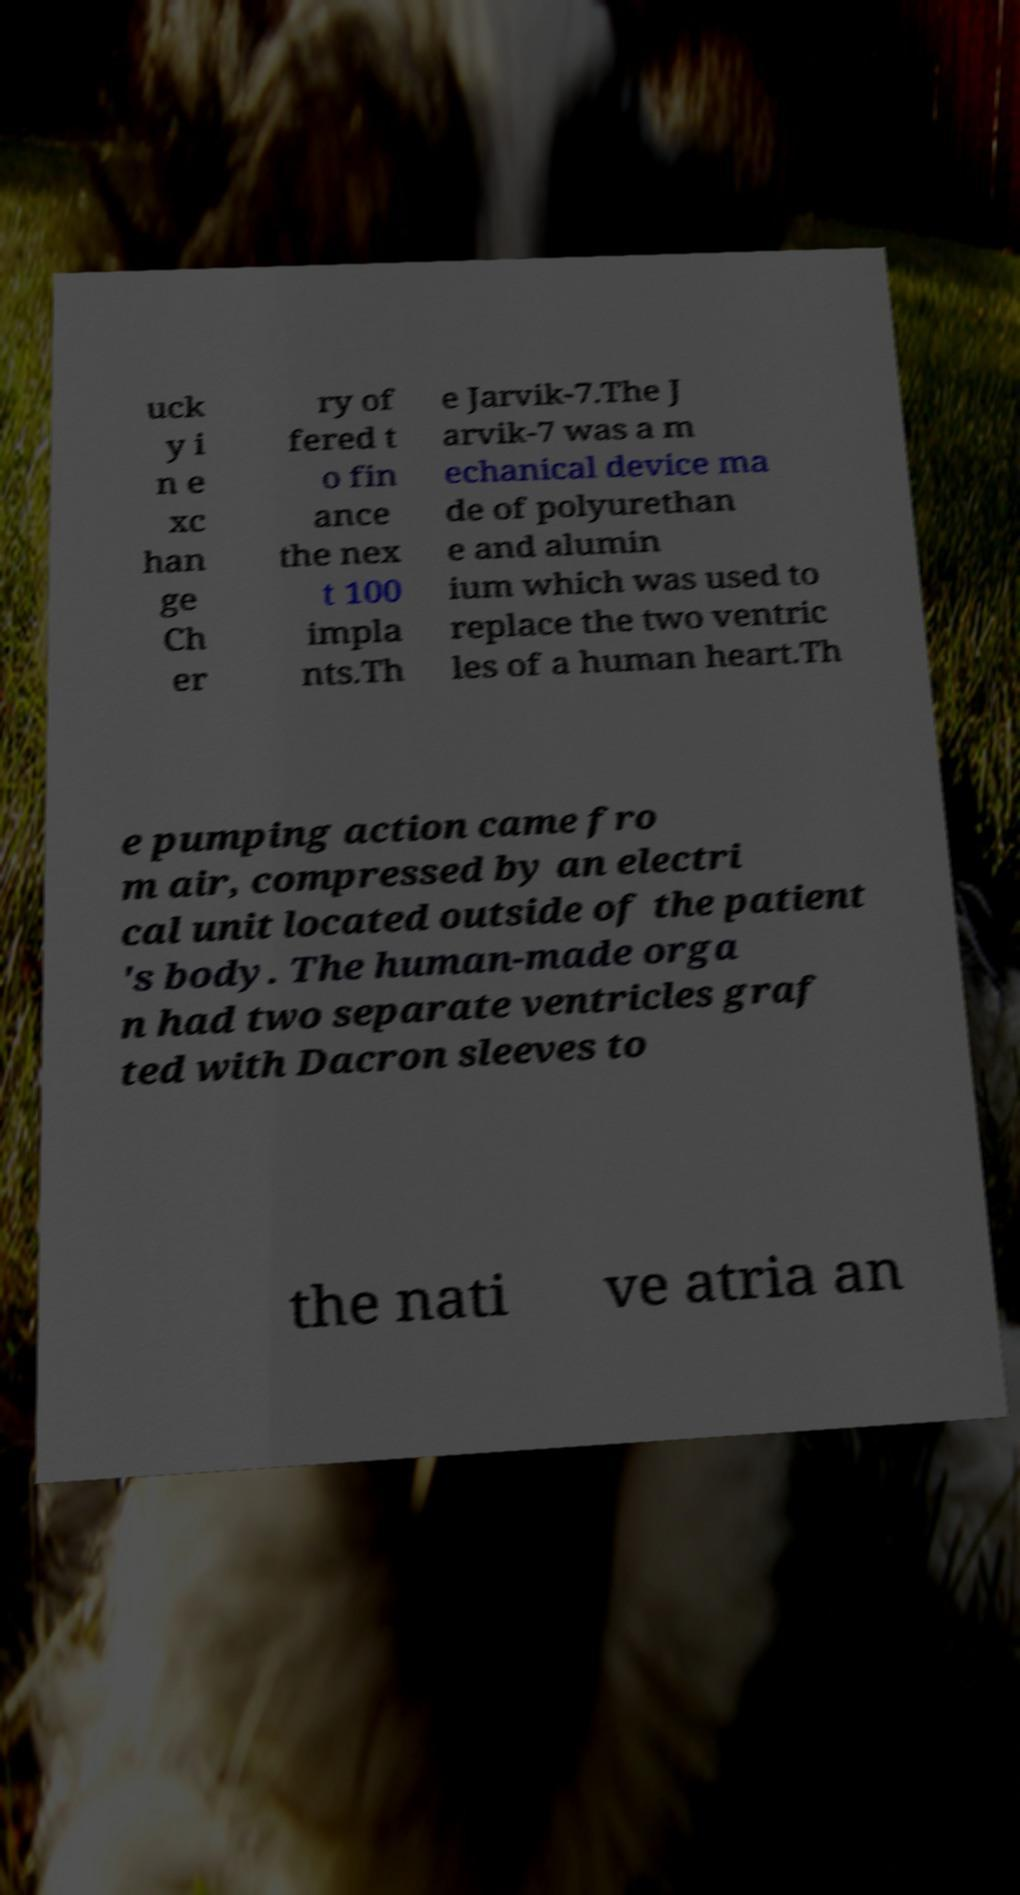Could you assist in decoding the text presented in this image and type it out clearly? uck y i n e xc han ge Ch er ry of fered t o fin ance the nex t 100 impla nts.Th e Jarvik-7.The J arvik-7 was a m echanical device ma de of polyurethan e and alumin ium which was used to replace the two ventric les of a human heart.Th e pumping action came fro m air, compressed by an electri cal unit located outside of the patient 's body. The human-made orga n had two separate ventricles graf ted with Dacron sleeves to the nati ve atria an 